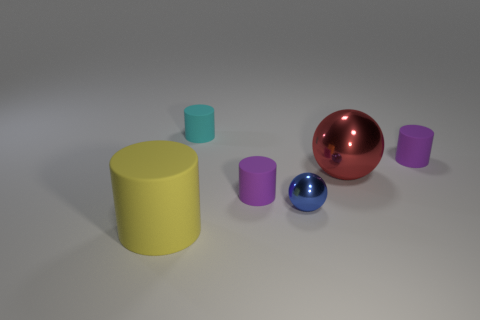Are there an equal number of small cylinders that are in front of the small metal ball and tiny blue metallic objects behind the small cyan cylinder?
Offer a very short reply. Yes. There is a matte thing that is in front of the small sphere; what size is it?
Offer a very short reply. Large. What material is the cylinder that is on the right side of the large thing to the right of the yellow rubber object?
Your response must be concise. Rubber. There is a tiny purple cylinder left of the small object that is on the right side of the blue sphere; what number of objects are to the left of it?
Provide a succinct answer. 2. Does the large object to the left of the cyan cylinder have the same material as the sphere that is in front of the red metallic ball?
Provide a succinct answer. No. How many other matte objects have the same shape as the cyan object?
Provide a short and direct response. 3. Is the number of small purple things behind the tiny shiny object greater than the number of cyan blocks?
Your answer should be compact. Yes. What is the shape of the tiny blue thing in front of the big object behind the yellow object in front of the tiny shiny object?
Keep it short and to the point. Sphere. There is a large thing that is to the right of the yellow object; is it the same shape as the small blue object right of the tiny cyan cylinder?
Give a very brief answer. Yes. What number of cubes are purple things or big red things?
Make the answer very short. 0. 